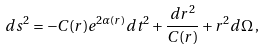Convert formula to latex. <formula><loc_0><loc_0><loc_500><loc_500>d s ^ { 2 } = - C ( r ) e ^ { 2 \alpha ( r ) } d t ^ { 2 } + \frac { d r ^ { 2 } } { C ( r ) } + r ^ { 2 } d \Omega \, ,</formula> 